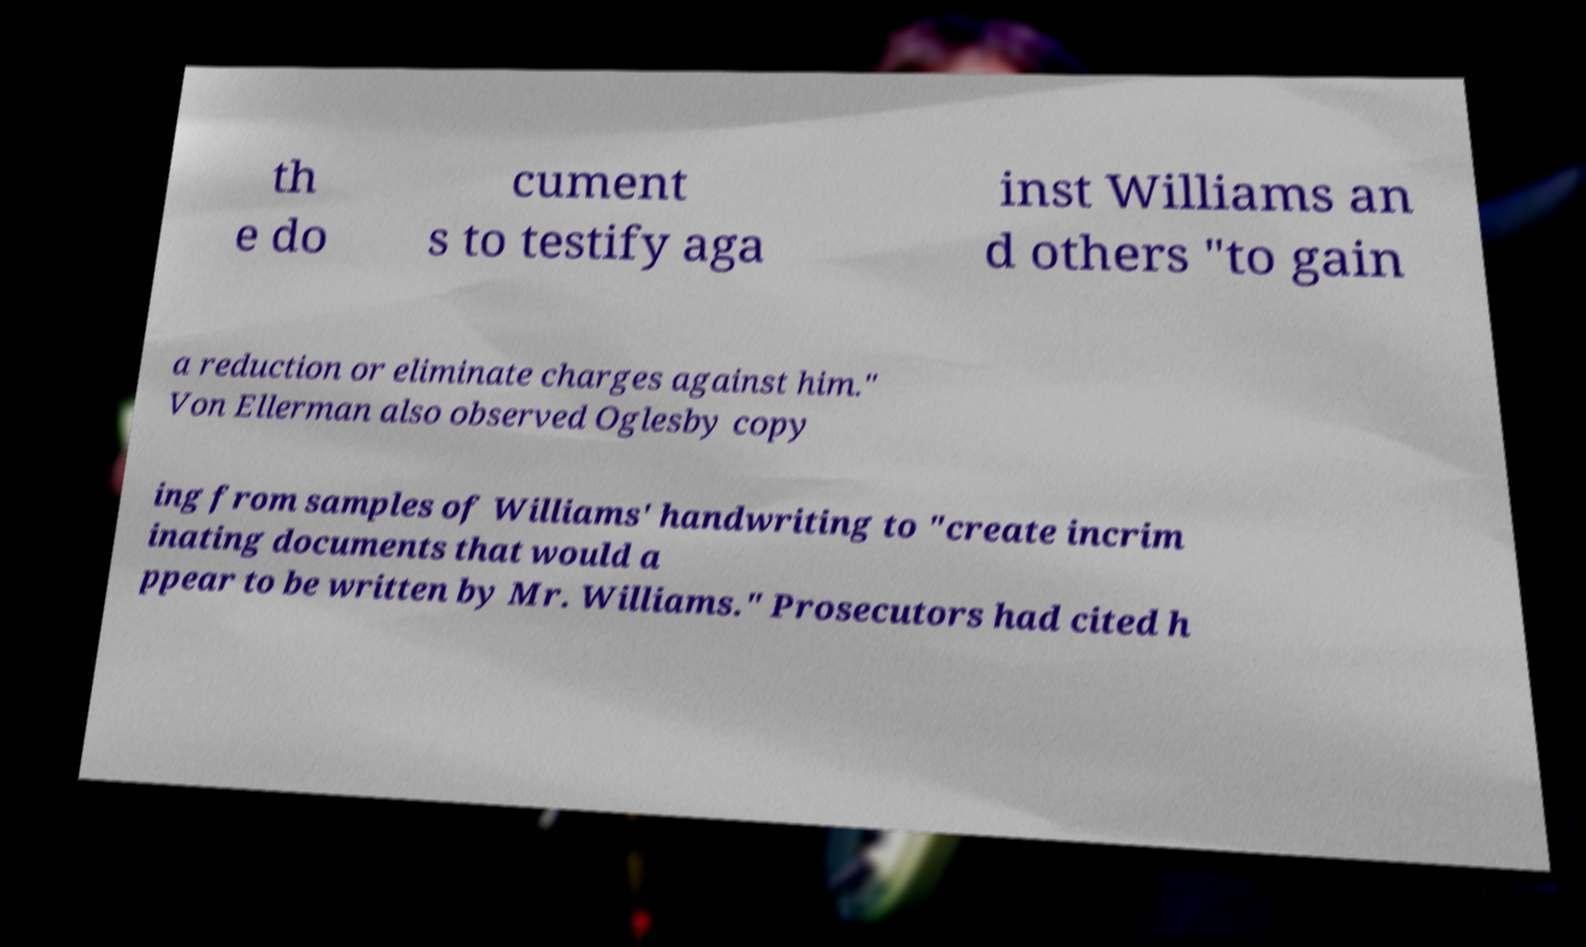Can you read and provide the text displayed in the image?This photo seems to have some interesting text. Can you extract and type it out for me? th e do cument s to testify aga inst Williams an d others "to gain a reduction or eliminate charges against him." Von Ellerman also observed Oglesby copy ing from samples of Williams' handwriting to "create incrim inating documents that would a ppear to be written by Mr. Williams." Prosecutors had cited h 